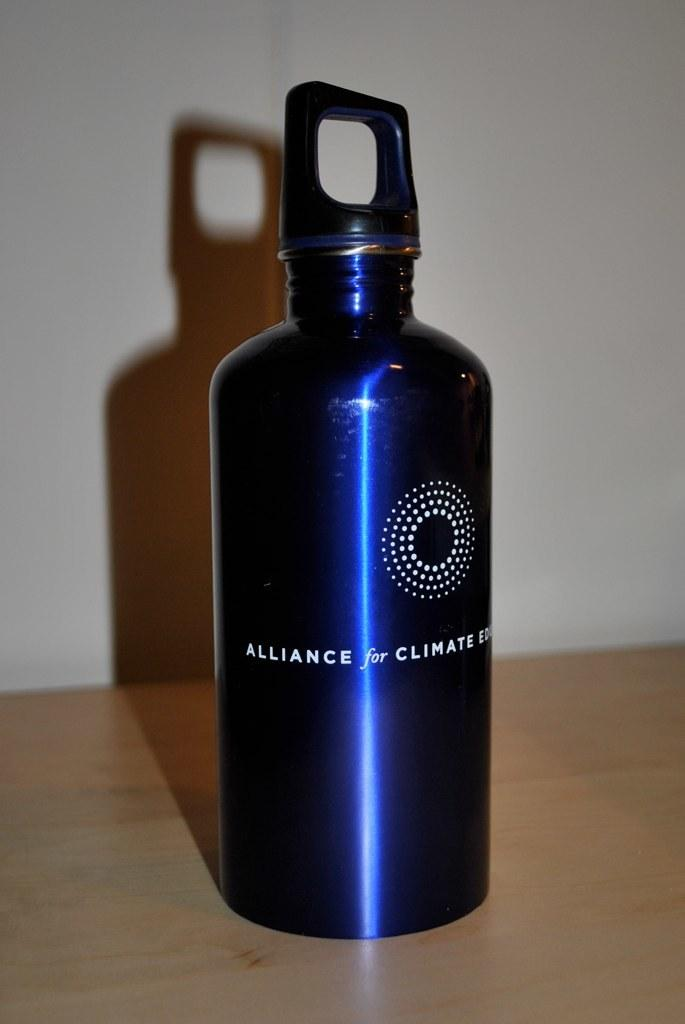<image>
Summarize the visual content of the image. A water bottle with Alliance for Climate written on it. 